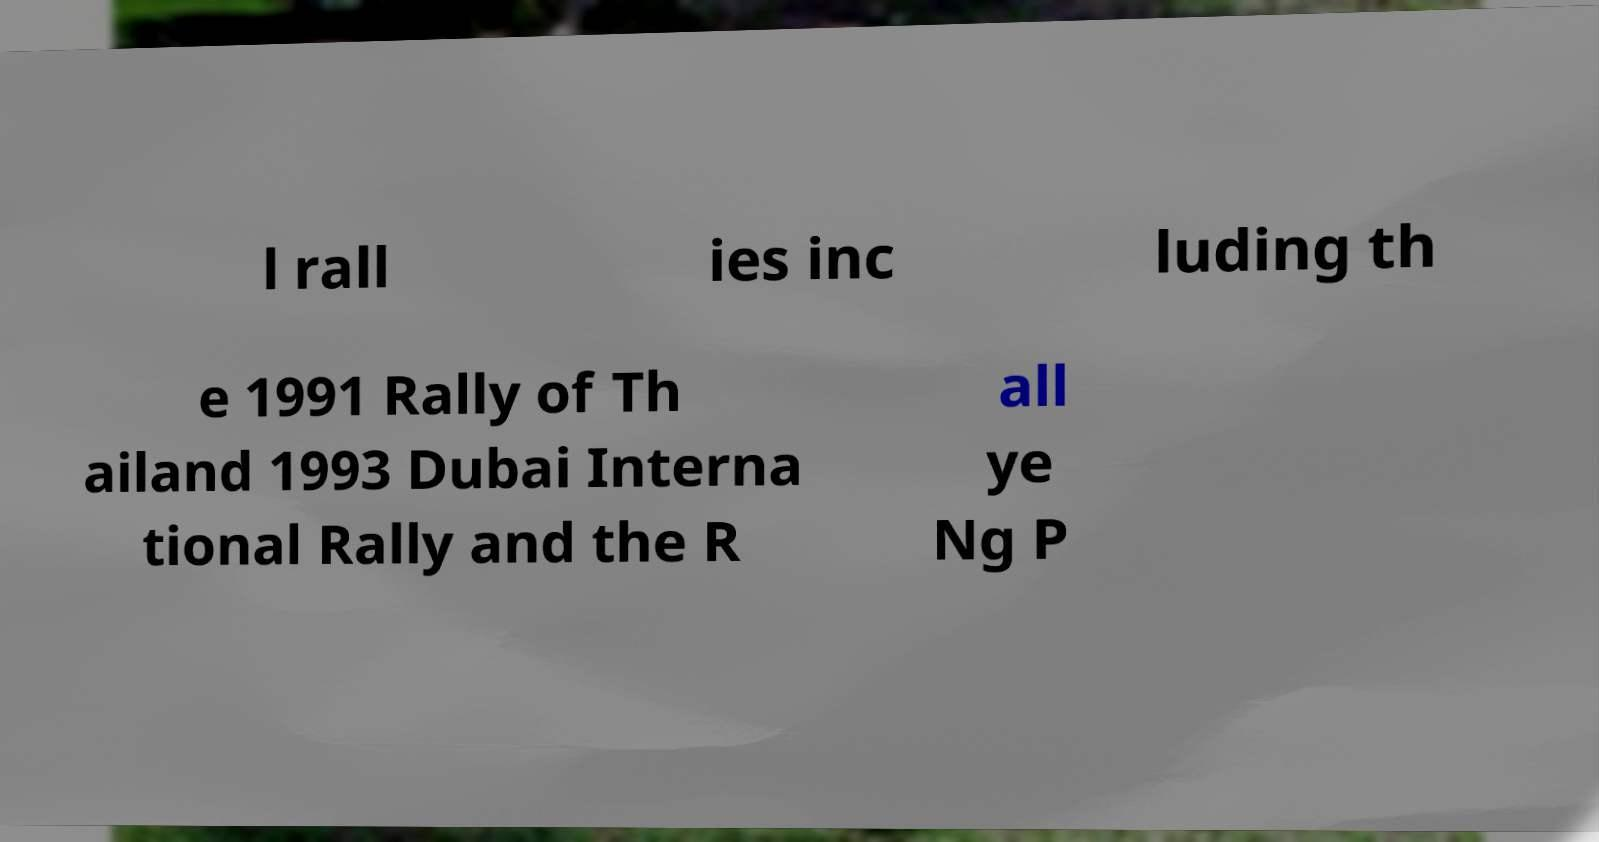Can you accurately transcribe the text from the provided image for me? l rall ies inc luding th e 1991 Rally of Th ailand 1993 Dubai Interna tional Rally and the R all ye Ng P 